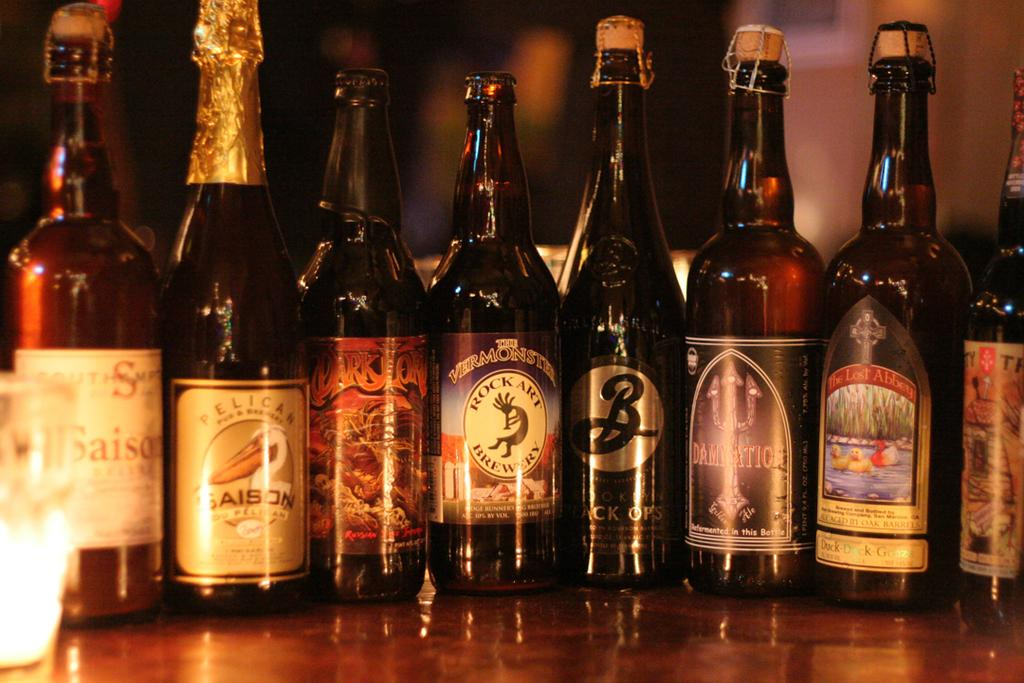What objects are on the table in the foreground of the image? There are liquor bottles on a table in the foreground. Where was the image taken? The image was taken in a bar shop. What can be seen in the background of the image? There is a wall visible in the background. What type of tail can be seen on the liquor bottles in the image? There are no tails present on the liquor bottles in the image. 